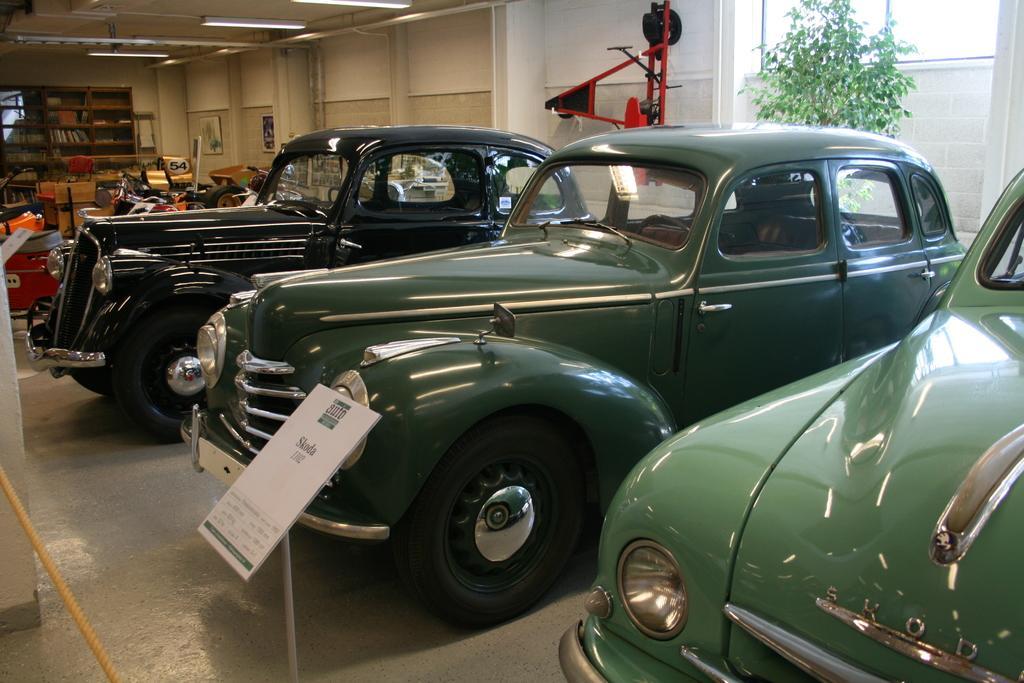Describe this image in one or two sentences. In this image, I can see the cars and vehicles on the floor. At the bottom of the image, there is a rope and a board with a stand. On the right side of the image, I can see a window, tree and an object attached to the wall. At the top of the image, there are tube lights attached to the ceiling. In the background, I can see the books in a rack and there are photo frames attached to the wall. 